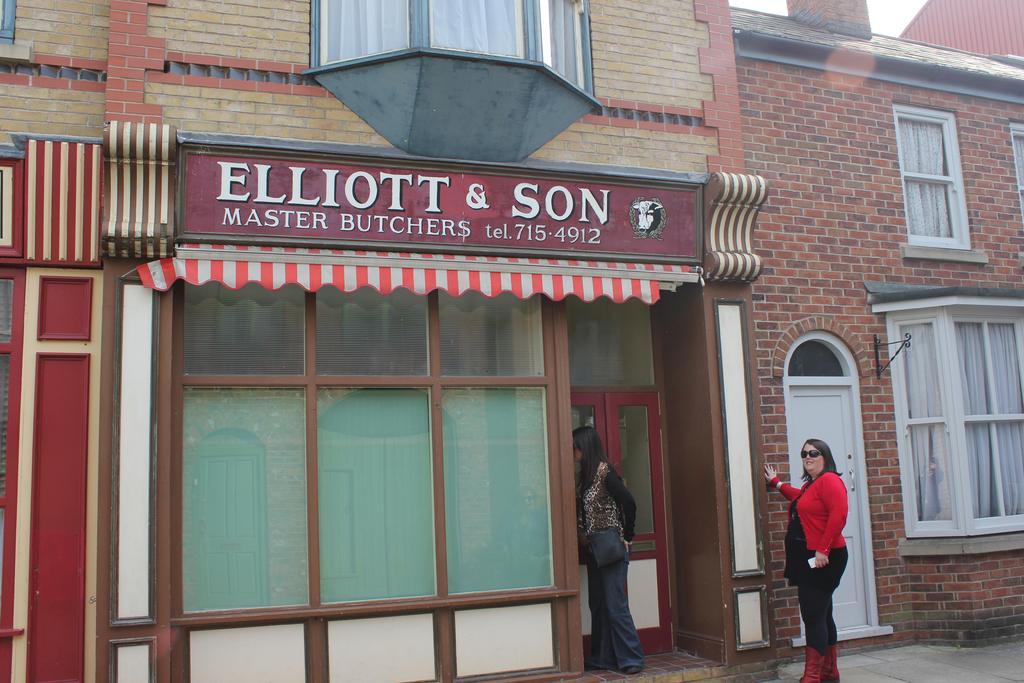Could you give a brief overview of what you see in this image? At the bottom of the image few people are standing. Behind them there are some buildings. 